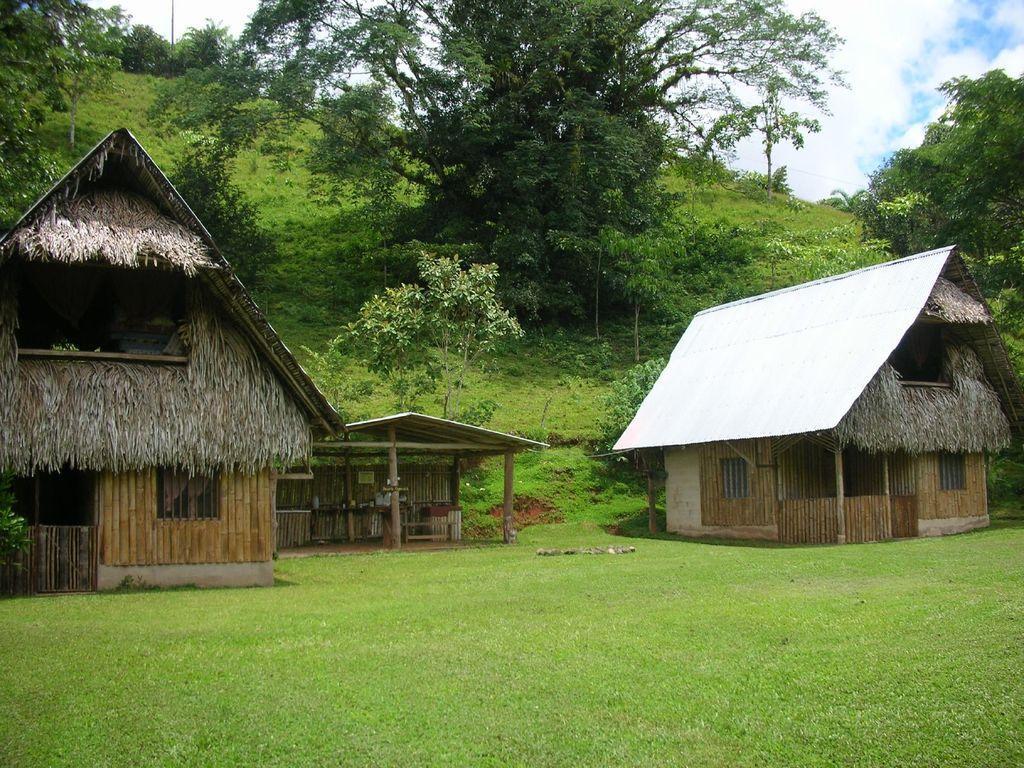Could you give a brief overview of what you see in this image? In this picture we observe three wooden houses and in the background there are trees everywhere. 